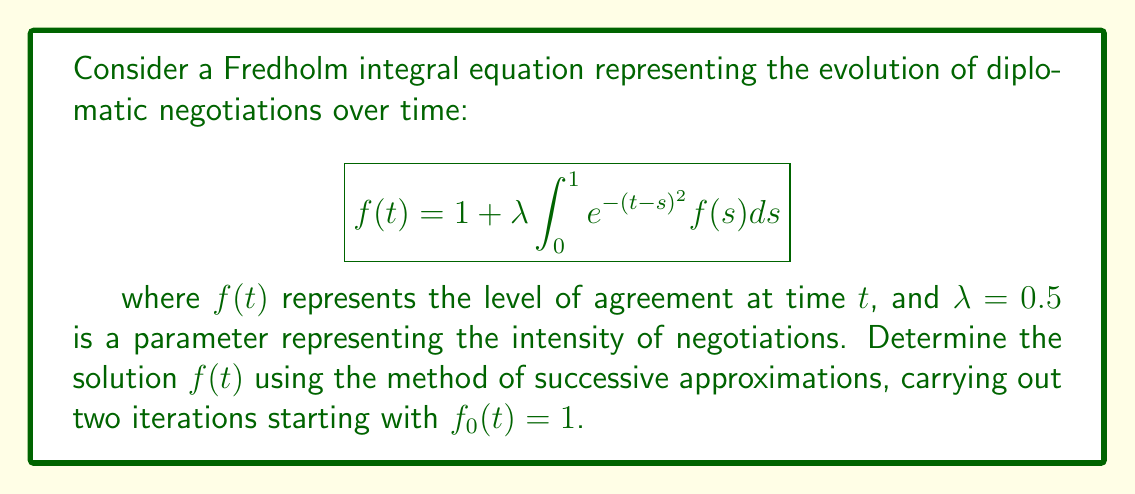Can you solve this math problem? To solve this Fredholm integral equation using successive approximations:

1) Start with $f_0(t) = 1$

2) First iteration:
   $$f_1(t) = 1 + 0.5 \int_0^1 e^{-(t-s)^2} \cdot 1 ds$$
   $$= 1 + 0.5 \int_0^1 e^{-(t-s)^2} ds$$
   The integral $\int_0^1 e^{-(t-s)^2} ds$ can be expressed in terms of the error function erf(x):
   $$\int_0^1 e^{-(t-s)^2} ds = \frac{\sqrt{\pi}}{2}[\text{erf}(t) - \text{erf}(t-1)]$$
   Thus,
   $$f_1(t) = 1 + 0.25\sqrt{\pi}[\text{erf}(t) - \text{erf}(t-1)]$$

3) Second iteration:
   $$f_2(t) = 1 + 0.5 \int_0^1 e^{-(t-s)^2} f_1(s) ds$$
   $$= 1 + 0.5 \int_0^1 e^{-(t-s)^2} [1 + 0.25\sqrt{\pi}(\text{erf}(s) - \text{erf}(s-1))] ds$$
   $$= 1 + 0.25\sqrt{\pi}[\text{erf}(t) - \text{erf}(t-1)] + 0.125\pi \int_0^1 e^{-(t-s)^2} [\text{erf}(s) - \text{erf}(s-1)] ds$$

The last integral doesn't have a simple closed form, but can be evaluated numerically for specific values of $t$.
Answer: $f(t) \approx 1 + 0.25\sqrt{\pi}[\text{erf}(t) - \text{erf}(t-1)] + 0.125\pi \int_0^1 e^{-(t-s)^2} [\text{erf}(s) - \text{erf}(s-1)] ds$ 